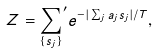<formula> <loc_0><loc_0><loc_500><loc_500>Z = { \sum _ { \{ s _ { j } \} } } ^ { \prime } e ^ { - | \sum _ { j } a _ { j } s _ { j } | / T } ,</formula> 